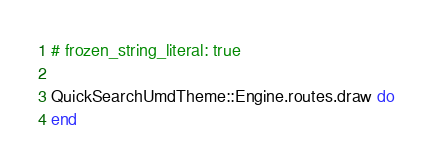Convert code to text. <code><loc_0><loc_0><loc_500><loc_500><_Ruby_># frozen_string_literal: true

QuickSearchUmdTheme::Engine.routes.draw do
end
</code> 